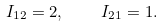<formula> <loc_0><loc_0><loc_500><loc_500>I _ { 1 2 } = 2 , \quad I _ { 2 1 } = 1 .</formula> 